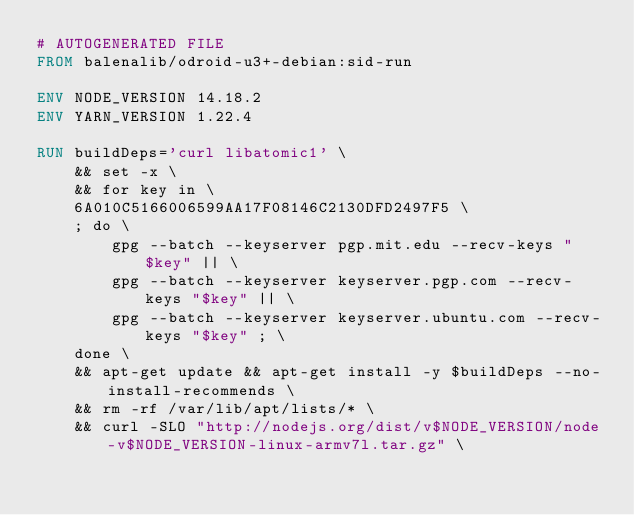<code> <loc_0><loc_0><loc_500><loc_500><_Dockerfile_># AUTOGENERATED FILE
FROM balenalib/odroid-u3+-debian:sid-run

ENV NODE_VERSION 14.18.2
ENV YARN_VERSION 1.22.4

RUN buildDeps='curl libatomic1' \
	&& set -x \
	&& for key in \
	6A010C5166006599AA17F08146C2130DFD2497F5 \
	; do \
		gpg --batch --keyserver pgp.mit.edu --recv-keys "$key" || \
		gpg --batch --keyserver keyserver.pgp.com --recv-keys "$key" || \
		gpg --batch --keyserver keyserver.ubuntu.com --recv-keys "$key" ; \
	done \
	&& apt-get update && apt-get install -y $buildDeps --no-install-recommends \
	&& rm -rf /var/lib/apt/lists/* \
	&& curl -SLO "http://nodejs.org/dist/v$NODE_VERSION/node-v$NODE_VERSION-linux-armv7l.tar.gz" \</code> 